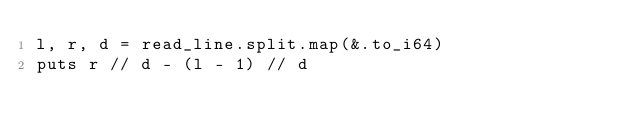<code> <loc_0><loc_0><loc_500><loc_500><_Crystal_>l, r, d = read_line.split.map(&.to_i64)
puts r // d - (l - 1) // d
</code> 